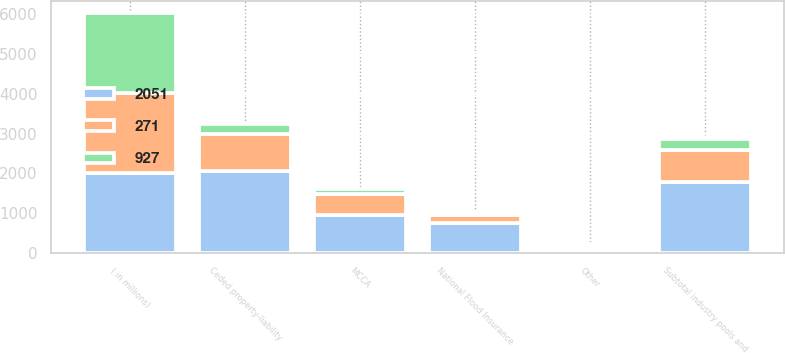Convert chart to OTSL. <chart><loc_0><loc_0><loc_500><loc_500><stacked_bar_chart><ecel><fcel>( in millions)<fcel>Ceded property-liability<fcel>MCCA<fcel>National Flood Insurance<fcel>Other<fcel>Subtotal industry pools and<nl><fcel>2051<fcel>2012<fcel>2051<fcel>962<fcel>758<fcel>70<fcel>1790<nl><fcel>271<fcel>2011<fcel>927<fcel>509<fcel>196<fcel>84<fcel>797<nl><fcel>927<fcel>2010<fcel>271<fcel>142<fcel>50<fcel>64<fcel>266<nl></chart> 